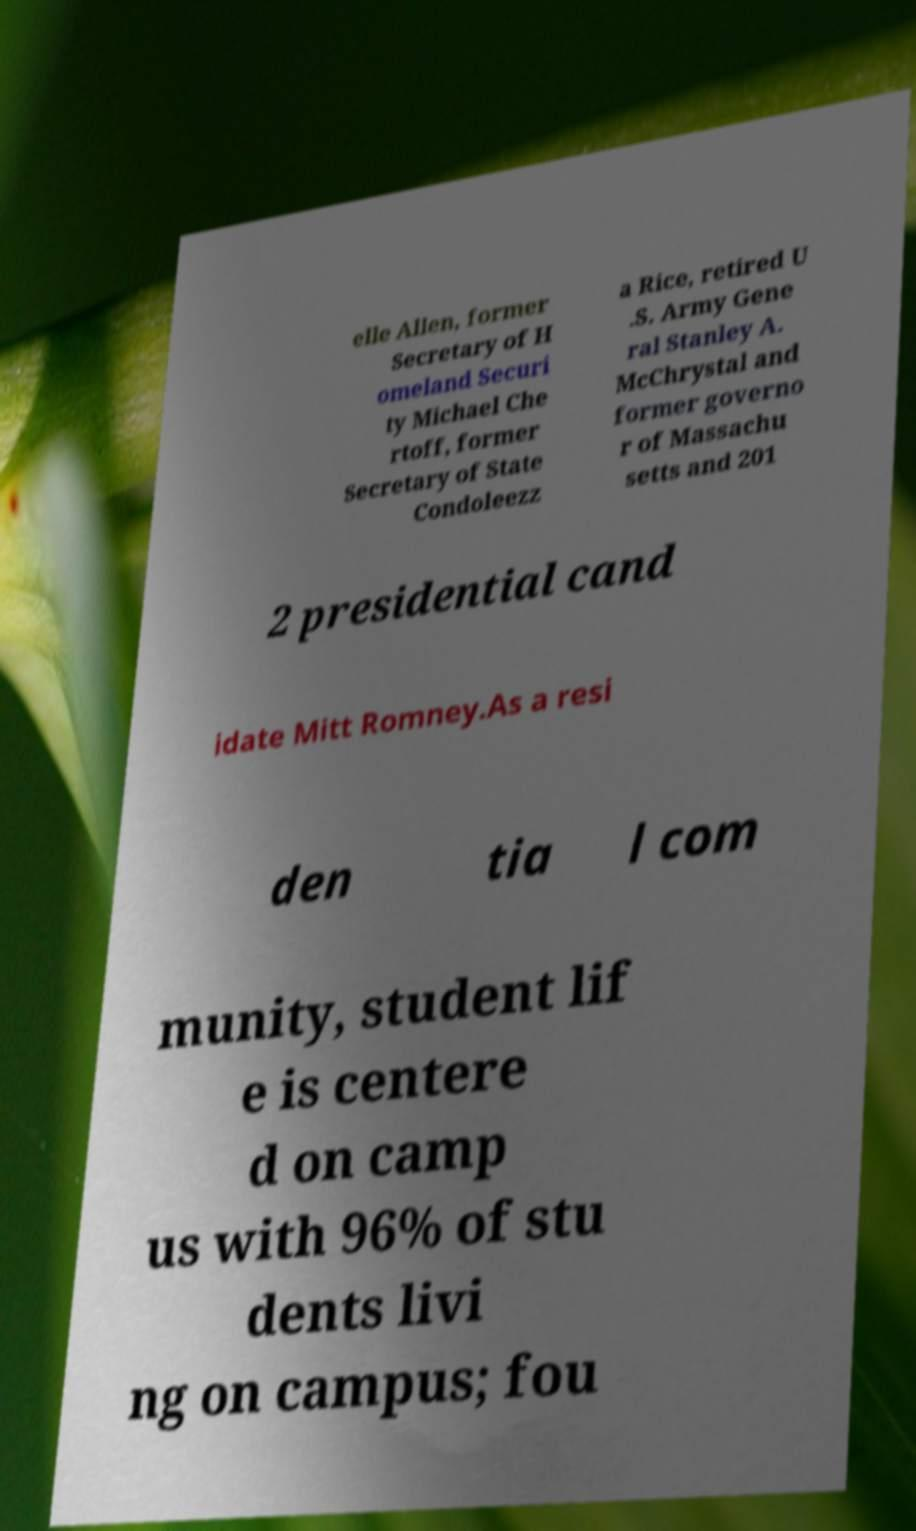Could you assist in decoding the text presented in this image and type it out clearly? elle Allen, former Secretary of H omeland Securi ty Michael Che rtoff, former Secretary of State Condoleezz a Rice, retired U .S. Army Gene ral Stanley A. McChrystal and former governo r of Massachu setts and 201 2 presidential cand idate Mitt Romney.As a resi den tia l com munity, student lif e is centere d on camp us with 96% of stu dents livi ng on campus; fou 